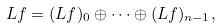Convert formula to latex. <formula><loc_0><loc_0><loc_500><loc_500>L f = ( L f ) _ { 0 } \oplus \cdots \oplus ( L f ) _ { n - 1 } ,</formula> 